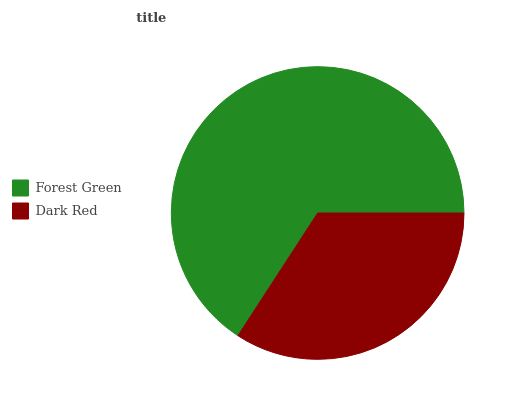Is Dark Red the minimum?
Answer yes or no. Yes. Is Forest Green the maximum?
Answer yes or no. Yes. Is Dark Red the maximum?
Answer yes or no. No. Is Forest Green greater than Dark Red?
Answer yes or no. Yes. Is Dark Red less than Forest Green?
Answer yes or no. Yes. Is Dark Red greater than Forest Green?
Answer yes or no. No. Is Forest Green less than Dark Red?
Answer yes or no. No. Is Forest Green the high median?
Answer yes or no. Yes. Is Dark Red the low median?
Answer yes or no. Yes. Is Dark Red the high median?
Answer yes or no. No. Is Forest Green the low median?
Answer yes or no. No. 